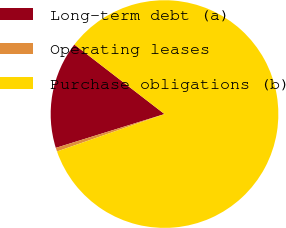Convert chart to OTSL. <chart><loc_0><loc_0><loc_500><loc_500><pie_chart><fcel>Long-term debt (a)<fcel>Operating leases<fcel>Purchase obligations (b)<nl><fcel>15.26%<fcel>0.53%<fcel>84.21%<nl></chart> 